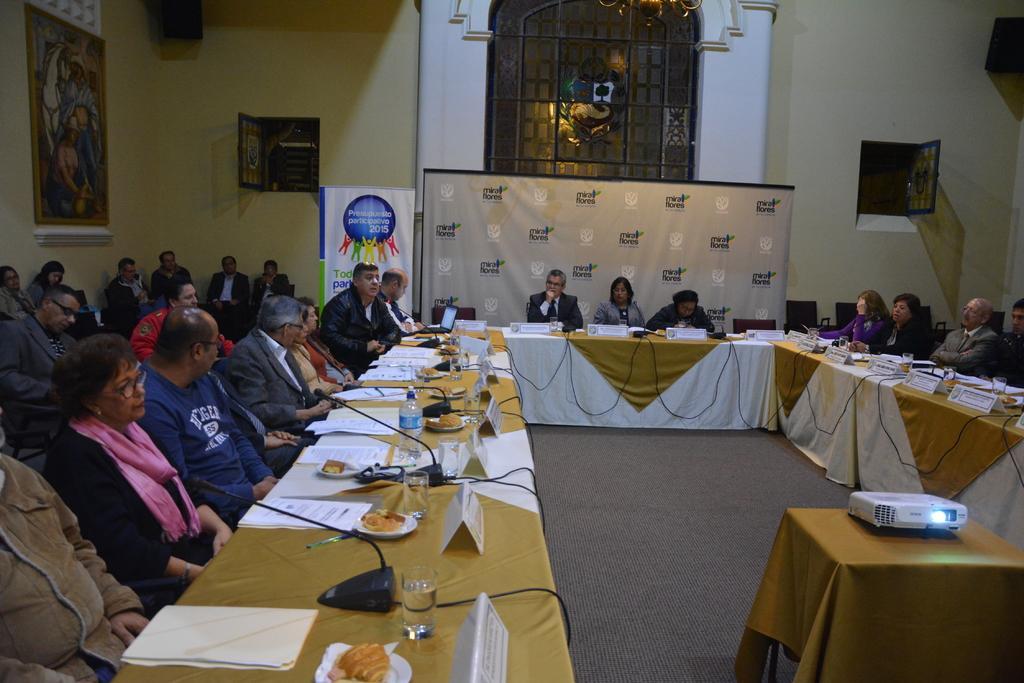Can you describe this image briefly? In this image we can see persons sitting on the chairs and tables are placed in front of them. On the tables we can see name boards, serving plates with food in them, mics, cables and papers. In the background there are wall hangings attached to the walls, windows, speakers, projector and an advertisement. 